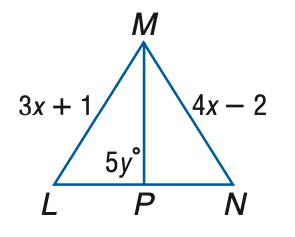Answer the mathemtical geometry problem and directly provide the correct option letter.
Question: Triangle L M N is equilateral, and M P bisects L N. Find x.
Choices: A: 3 B: 4 C: 5 D: 6 A 